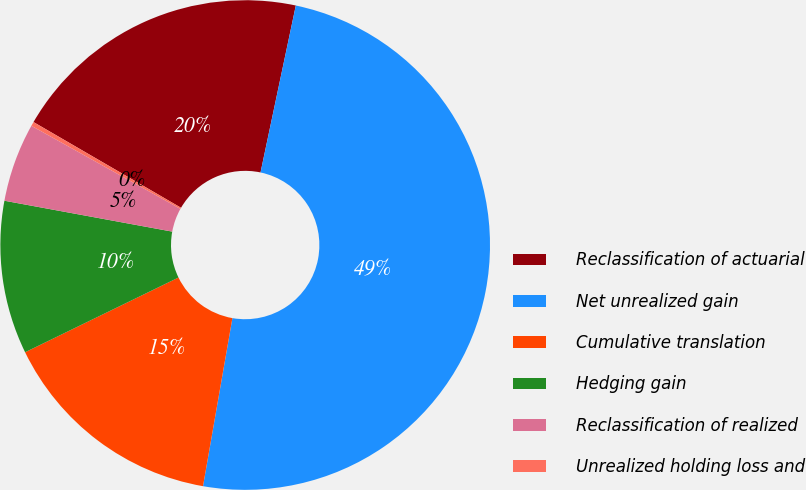Convert chart. <chart><loc_0><loc_0><loc_500><loc_500><pie_chart><fcel>Reclassification of actuarial<fcel>Net unrealized gain<fcel>Cumulative translation<fcel>Hedging gain<fcel>Reclassification of realized<fcel>Unrealized holding loss and<nl><fcel>19.94%<fcel>49.44%<fcel>15.03%<fcel>10.11%<fcel>5.2%<fcel>0.28%<nl></chart> 